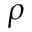<formula> <loc_0><loc_0><loc_500><loc_500>\rho</formula> 